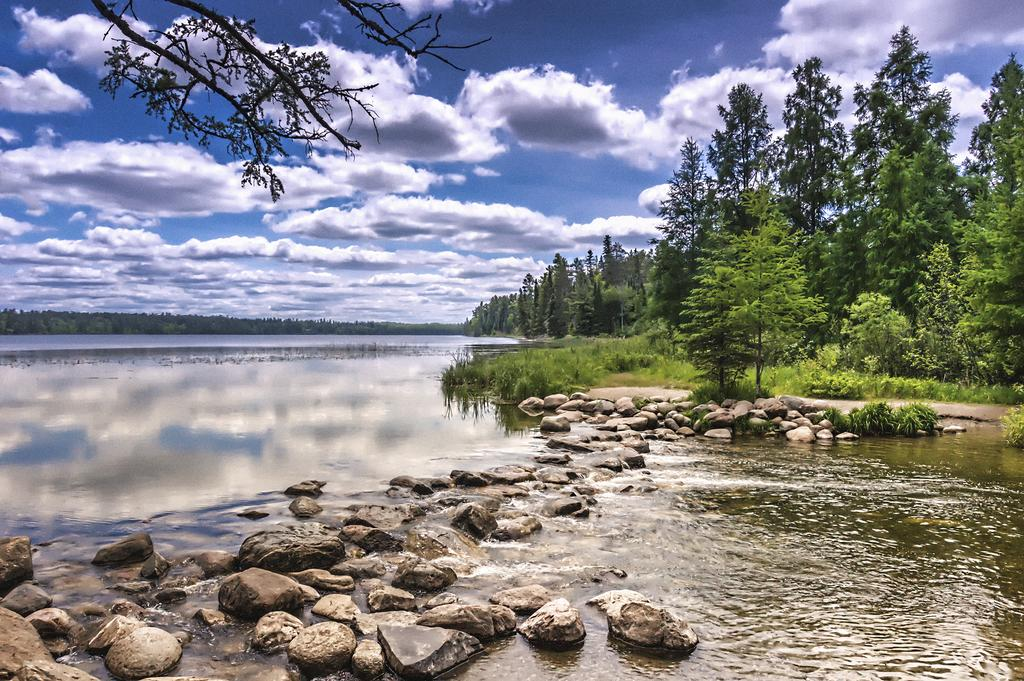What is present at the bottom of the image? There is water at the bottom of the image. What can be found in the water? There are stones in the water. What is located in the middle of the image? There are trees in the middle of the image. What is visible at the top of the image? There are clouds and the sky visible at the top of the image. What joke is being told by the rat in the image? There is no rat present in the image, and therefore no joke being told. What advice is being given by the clouds in the image? There are no characters or entities in the clouds to provide advice in the image. 